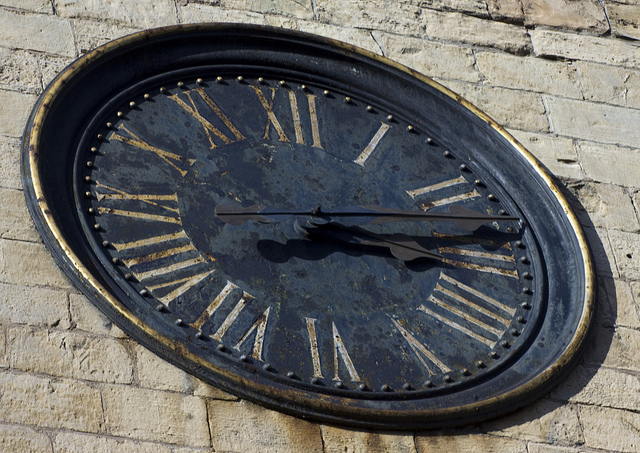Can you describe the design and condition of the clock? The clock has a vintage design with a rich sense of history. The Roman numerals are distinctly spaced around the edge, and the hands are in a classic style that suggests elegance and antiquity. The clock appears weathered and aged, giving it character and suggesting it has been a fixture on this surface for a considerable period of time. 